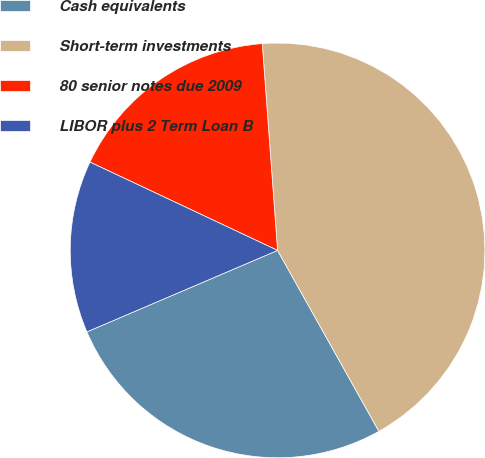<chart> <loc_0><loc_0><loc_500><loc_500><pie_chart><fcel>Cash equivalents<fcel>Short-term investments<fcel>80 senior notes due 2009<fcel>LIBOR plus 2 Term Loan B<nl><fcel>26.7%<fcel>43.05%<fcel>16.82%<fcel>13.43%<nl></chart> 